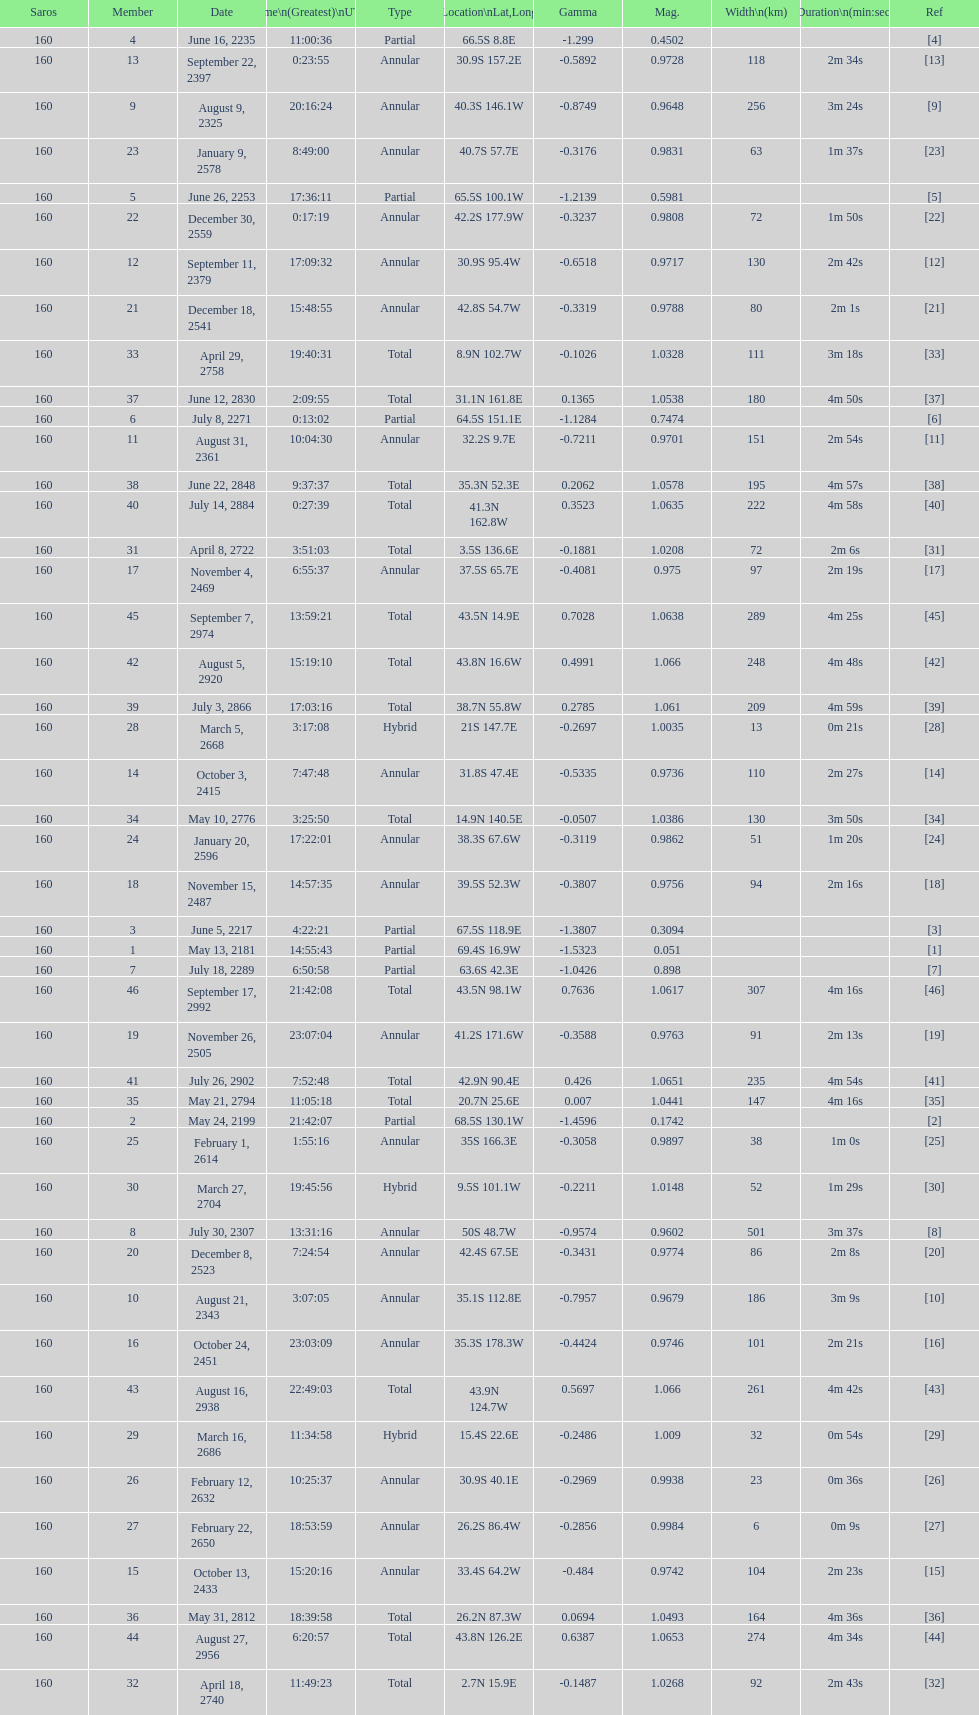Parse the full table. {'header': ['Saros', 'Member', 'Date', 'Time\\n(Greatest)\\nUTC', 'Type', 'Location\\nLat,Long', 'Gamma', 'Mag.', 'Width\\n(km)', 'Duration\\n(min:sec)', 'Ref'], 'rows': [['160', '4', 'June 16, 2235', '11:00:36', 'Partial', '66.5S 8.8E', '-1.299', '0.4502', '', '', '[4]'], ['160', '13', 'September 22, 2397', '0:23:55', 'Annular', '30.9S 157.2E', '-0.5892', '0.9728', '118', '2m 34s', '[13]'], ['160', '9', 'August 9, 2325', '20:16:24', 'Annular', '40.3S 146.1W', '-0.8749', '0.9648', '256', '3m 24s', '[9]'], ['160', '23', 'January 9, 2578', '8:49:00', 'Annular', '40.7S 57.7E', '-0.3176', '0.9831', '63', '1m 37s', '[23]'], ['160', '5', 'June 26, 2253', '17:36:11', 'Partial', '65.5S 100.1W', '-1.2139', '0.5981', '', '', '[5]'], ['160', '22', 'December 30, 2559', '0:17:19', 'Annular', '42.2S 177.9W', '-0.3237', '0.9808', '72', '1m 50s', '[22]'], ['160', '12', 'September 11, 2379', '17:09:32', 'Annular', '30.9S 95.4W', '-0.6518', '0.9717', '130', '2m 42s', '[12]'], ['160', '21', 'December 18, 2541', '15:48:55', 'Annular', '42.8S 54.7W', '-0.3319', '0.9788', '80', '2m 1s', '[21]'], ['160', '33', 'April 29, 2758', '19:40:31', 'Total', '8.9N 102.7W', '-0.1026', '1.0328', '111', '3m 18s', '[33]'], ['160', '37', 'June 12, 2830', '2:09:55', 'Total', '31.1N 161.8E', '0.1365', '1.0538', '180', '4m 50s', '[37]'], ['160', '6', 'July 8, 2271', '0:13:02', 'Partial', '64.5S 151.1E', '-1.1284', '0.7474', '', '', '[6]'], ['160', '11', 'August 31, 2361', '10:04:30', 'Annular', '32.2S 9.7E', '-0.7211', '0.9701', '151', '2m 54s', '[11]'], ['160', '38', 'June 22, 2848', '9:37:37', 'Total', '35.3N 52.3E', '0.2062', '1.0578', '195', '4m 57s', '[38]'], ['160', '40', 'July 14, 2884', '0:27:39', 'Total', '41.3N 162.8W', '0.3523', '1.0635', '222', '4m 58s', '[40]'], ['160', '31', 'April 8, 2722', '3:51:03', 'Total', '3.5S 136.6E', '-0.1881', '1.0208', '72', '2m 6s', '[31]'], ['160', '17', 'November 4, 2469', '6:55:37', 'Annular', '37.5S 65.7E', '-0.4081', '0.975', '97', '2m 19s', '[17]'], ['160', '45', 'September 7, 2974', '13:59:21', 'Total', '43.5N 14.9E', '0.7028', '1.0638', '289', '4m 25s', '[45]'], ['160', '42', 'August 5, 2920', '15:19:10', 'Total', '43.8N 16.6W', '0.4991', '1.066', '248', '4m 48s', '[42]'], ['160', '39', 'July 3, 2866', '17:03:16', 'Total', '38.7N 55.8W', '0.2785', '1.061', '209', '4m 59s', '[39]'], ['160', '28', 'March 5, 2668', '3:17:08', 'Hybrid', '21S 147.7E', '-0.2697', '1.0035', '13', '0m 21s', '[28]'], ['160', '14', 'October 3, 2415', '7:47:48', 'Annular', '31.8S 47.4E', '-0.5335', '0.9736', '110', '2m 27s', '[14]'], ['160', '34', 'May 10, 2776', '3:25:50', 'Total', '14.9N 140.5E', '-0.0507', '1.0386', '130', '3m 50s', '[34]'], ['160', '24', 'January 20, 2596', '17:22:01', 'Annular', '38.3S 67.6W', '-0.3119', '0.9862', '51', '1m 20s', '[24]'], ['160', '18', 'November 15, 2487', '14:57:35', 'Annular', '39.5S 52.3W', '-0.3807', '0.9756', '94', '2m 16s', '[18]'], ['160', '3', 'June 5, 2217', '4:22:21', 'Partial', '67.5S 118.9E', '-1.3807', '0.3094', '', '', '[3]'], ['160', '1', 'May 13, 2181', '14:55:43', 'Partial', '69.4S 16.9W', '-1.5323', '0.051', '', '', '[1]'], ['160', '7', 'July 18, 2289', '6:50:58', 'Partial', '63.6S 42.3E', '-1.0426', '0.898', '', '', '[7]'], ['160', '46', 'September 17, 2992', '21:42:08', 'Total', '43.5N 98.1W', '0.7636', '1.0617', '307', '4m 16s', '[46]'], ['160', '19', 'November 26, 2505', '23:07:04', 'Annular', '41.2S 171.6W', '-0.3588', '0.9763', '91', '2m 13s', '[19]'], ['160', '41', 'July 26, 2902', '7:52:48', 'Total', '42.9N 90.4E', '0.426', '1.0651', '235', '4m 54s', '[41]'], ['160', '35', 'May 21, 2794', '11:05:18', 'Total', '20.7N 25.6E', '0.007', '1.0441', '147', '4m 16s', '[35]'], ['160', '2', 'May 24, 2199', '21:42:07', 'Partial', '68.5S 130.1W', '-1.4596', '0.1742', '', '', '[2]'], ['160', '25', 'February 1, 2614', '1:55:16', 'Annular', '35S 166.3E', '-0.3058', '0.9897', '38', '1m 0s', '[25]'], ['160', '30', 'March 27, 2704', '19:45:56', 'Hybrid', '9.5S 101.1W', '-0.2211', '1.0148', '52', '1m 29s', '[30]'], ['160', '8', 'July 30, 2307', '13:31:16', 'Annular', '50S 48.7W', '-0.9574', '0.9602', '501', '3m 37s', '[8]'], ['160', '20', 'December 8, 2523', '7:24:54', 'Annular', '42.4S 67.5E', '-0.3431', '0.9774', '86', '2m 8s', '[20]'], ['160', '10', 'August 21, 2343', '3:07:05', 'Annular', '35.1S 112.8E', '-0.7957', '0.9679', '186', '3m 9s', '[10]'], ['160', '16', 'October 24, 2451', '23:03:09', 'Annular', '35.3S 178.3W', '-0.4424', '0.9746', '101', '2m 21s', '[16]'], ['160', '43', 'August 16, 2938', '22:49:03', 'Total', '43.9N 124.7W', '0.5697', '1.066', '261', '4m 42s', '[43]'], ['160', '29', 'March 16, 2686', '11:34:58', 'Hybrid', '15.4S 22.6E', '-0.2486', '1.009', '32', '0m 54s', '[29]'], ['160', '26', 'February 12, 2632', '10:25:37', 'Annular', '30.9S 40.1E', '-0.2969', '0.9938', '23', '0m 36s', '[26]'], ['160', '27', 'February 22, 2650', '18:53:59', 'Annular', '26.2S 86.4W', '-0.2856', '0.9984', '6', '0m 9s', '[27]'], ['160', '15', 'October 13, 2433', '15:20:16', 'Annular', '33.4S 64.2W', '-0.484', '0.9742', '104', '2m 23s', '[15]'], ['160', '36', 'May 31, 2812', '18:39:58', 'Total', '26.2N 87.3W', '0.0694', '1.0493', '164', '4m 36s', '[36]'], ['160', '44', 'August 27, 2956', '6:20:57', 'Total', '43.8N 126.2E', '0.6387', '1.0653', '274', '4m 34s', '[44]'], ['160', '32', 'April 18, 2740', '11:49:23', 'Total', '2.7N 15.9E', '-0.1487', '1.0268', '92', '2m 43s', '[32]']]} Name one that has the same latitude as member number 12. 13. 